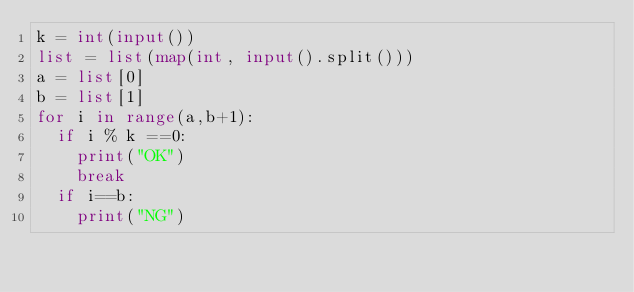Convert code to text. <code><loc_0><loc_0><loc_500><loc_500><_Python_>k = int(input())
list = list(map(int, input().split()))
a = list[0]
b = list[1]
for i in range(a,b+1):
  if i % k ==0:
    print("OK")
    break
  if i==b:
    print("NG")</code> 